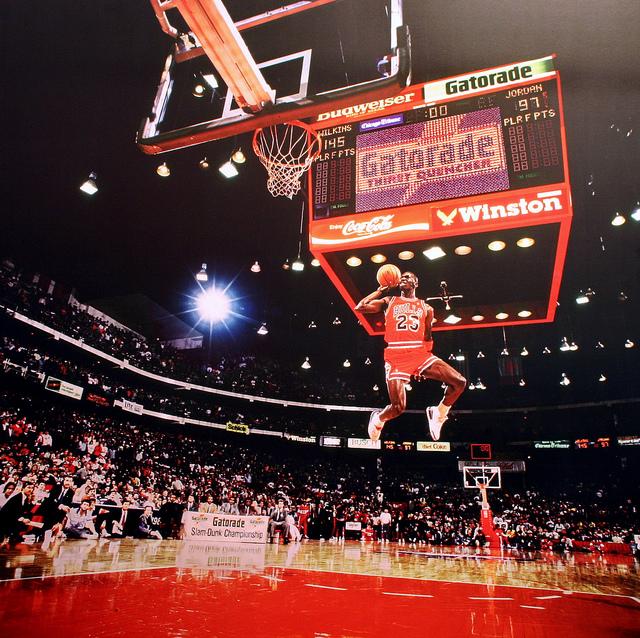Who is this athlete?
Keep it brief. Michael jordan. Is the place crowded?
Concise answer only. Yes. What cigarette brand is advertised?
Quick response, please. Winston. 